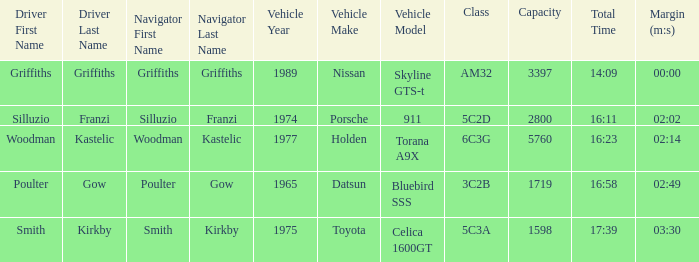Which vehicle has a class 6c3g? 1977 Holden Torana A9X. 